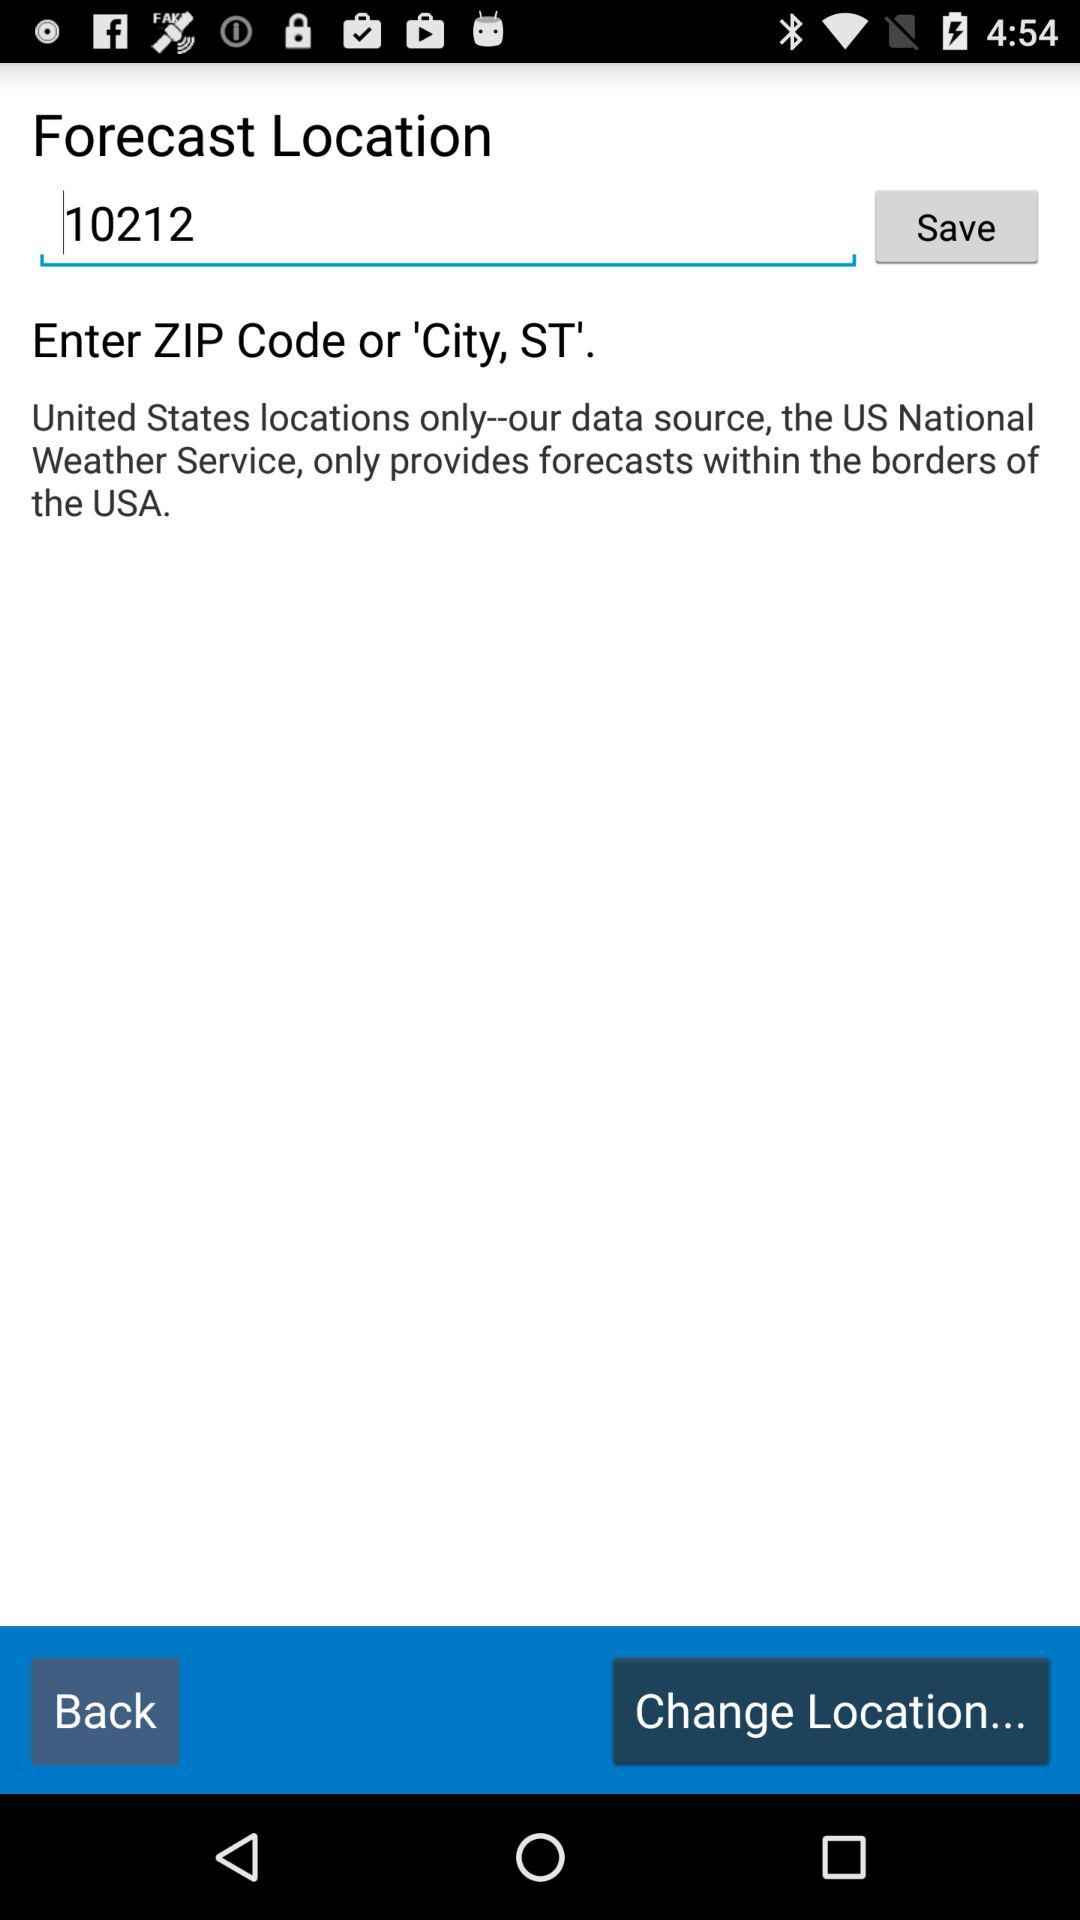What is the zip code? The zip code is 10212. 